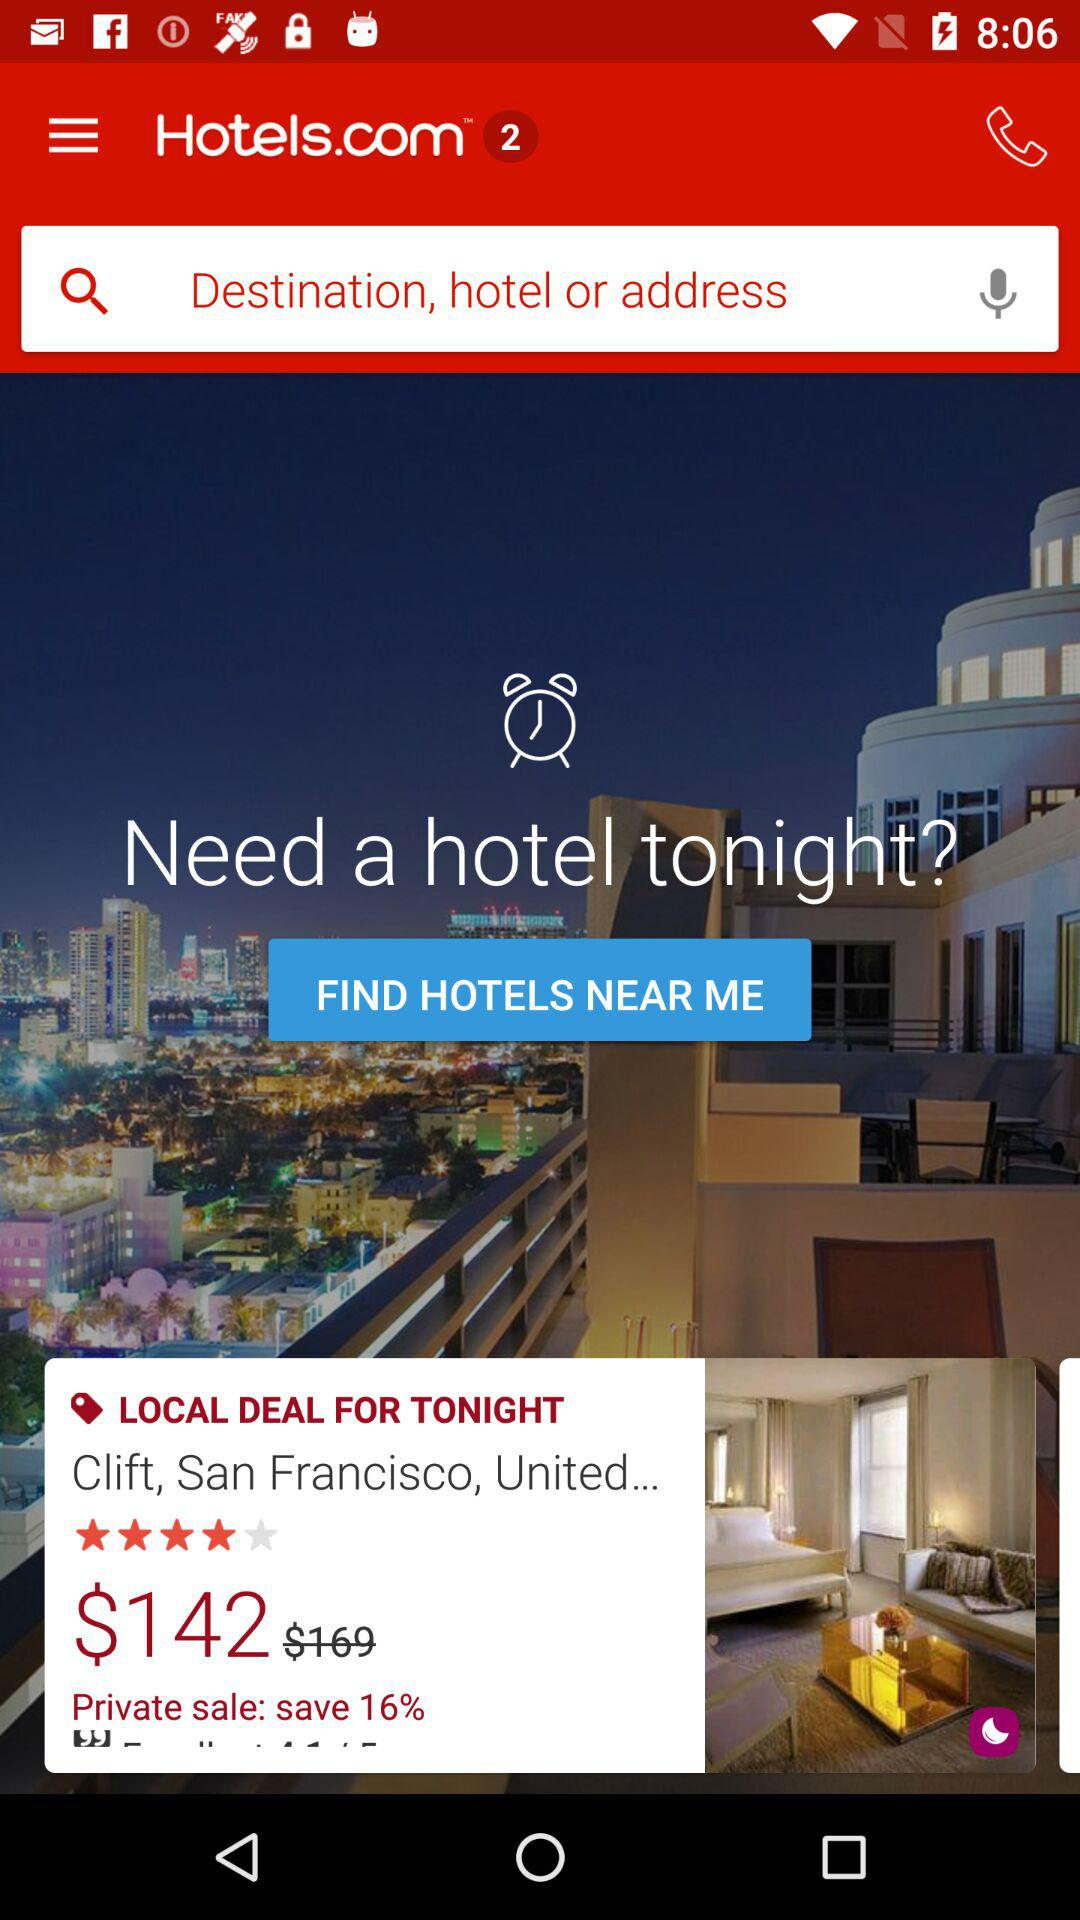What is the application name? The application name is "Hotels.com". 